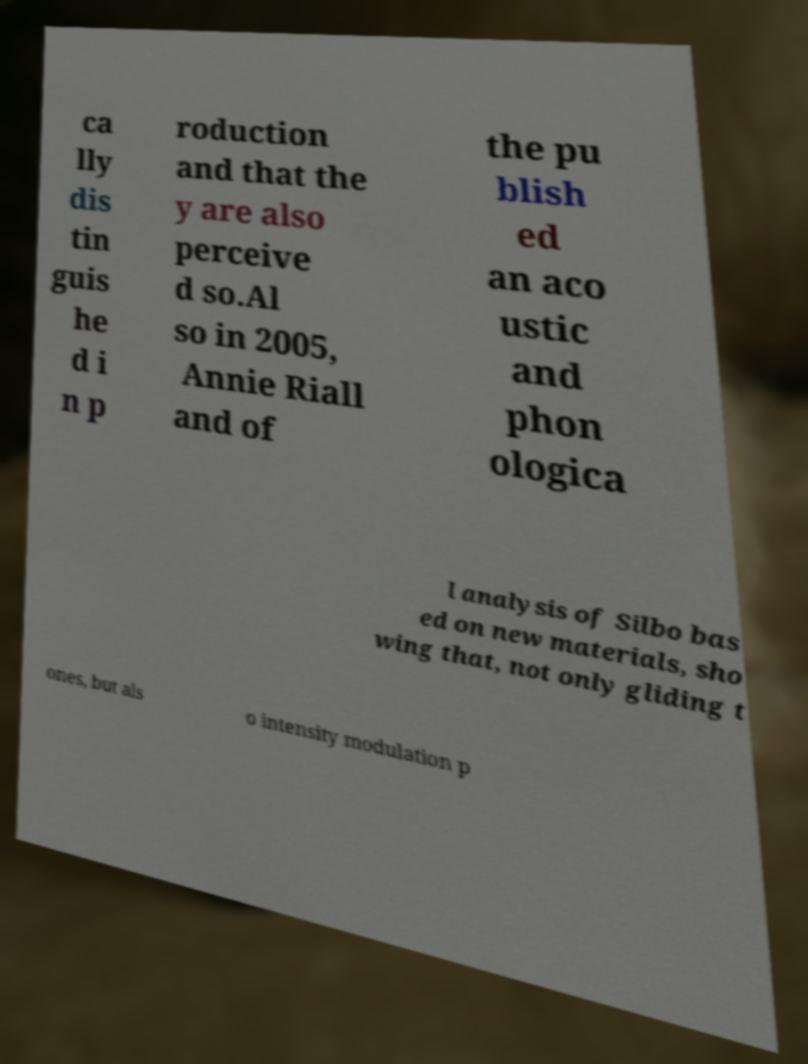For documentation purposes, I need the text within this image transcribed. Could you provide that? ca lly dis tin guis he d i n p roduction and that the y are also perceive d so.Al so in 2005, Annie Riall and of the pu blish ed an aco ustic and phon ologica l analysis of Silbo bas ed on new materials, sho wing that, not only gliding t ones, but als o intensity modulation p 